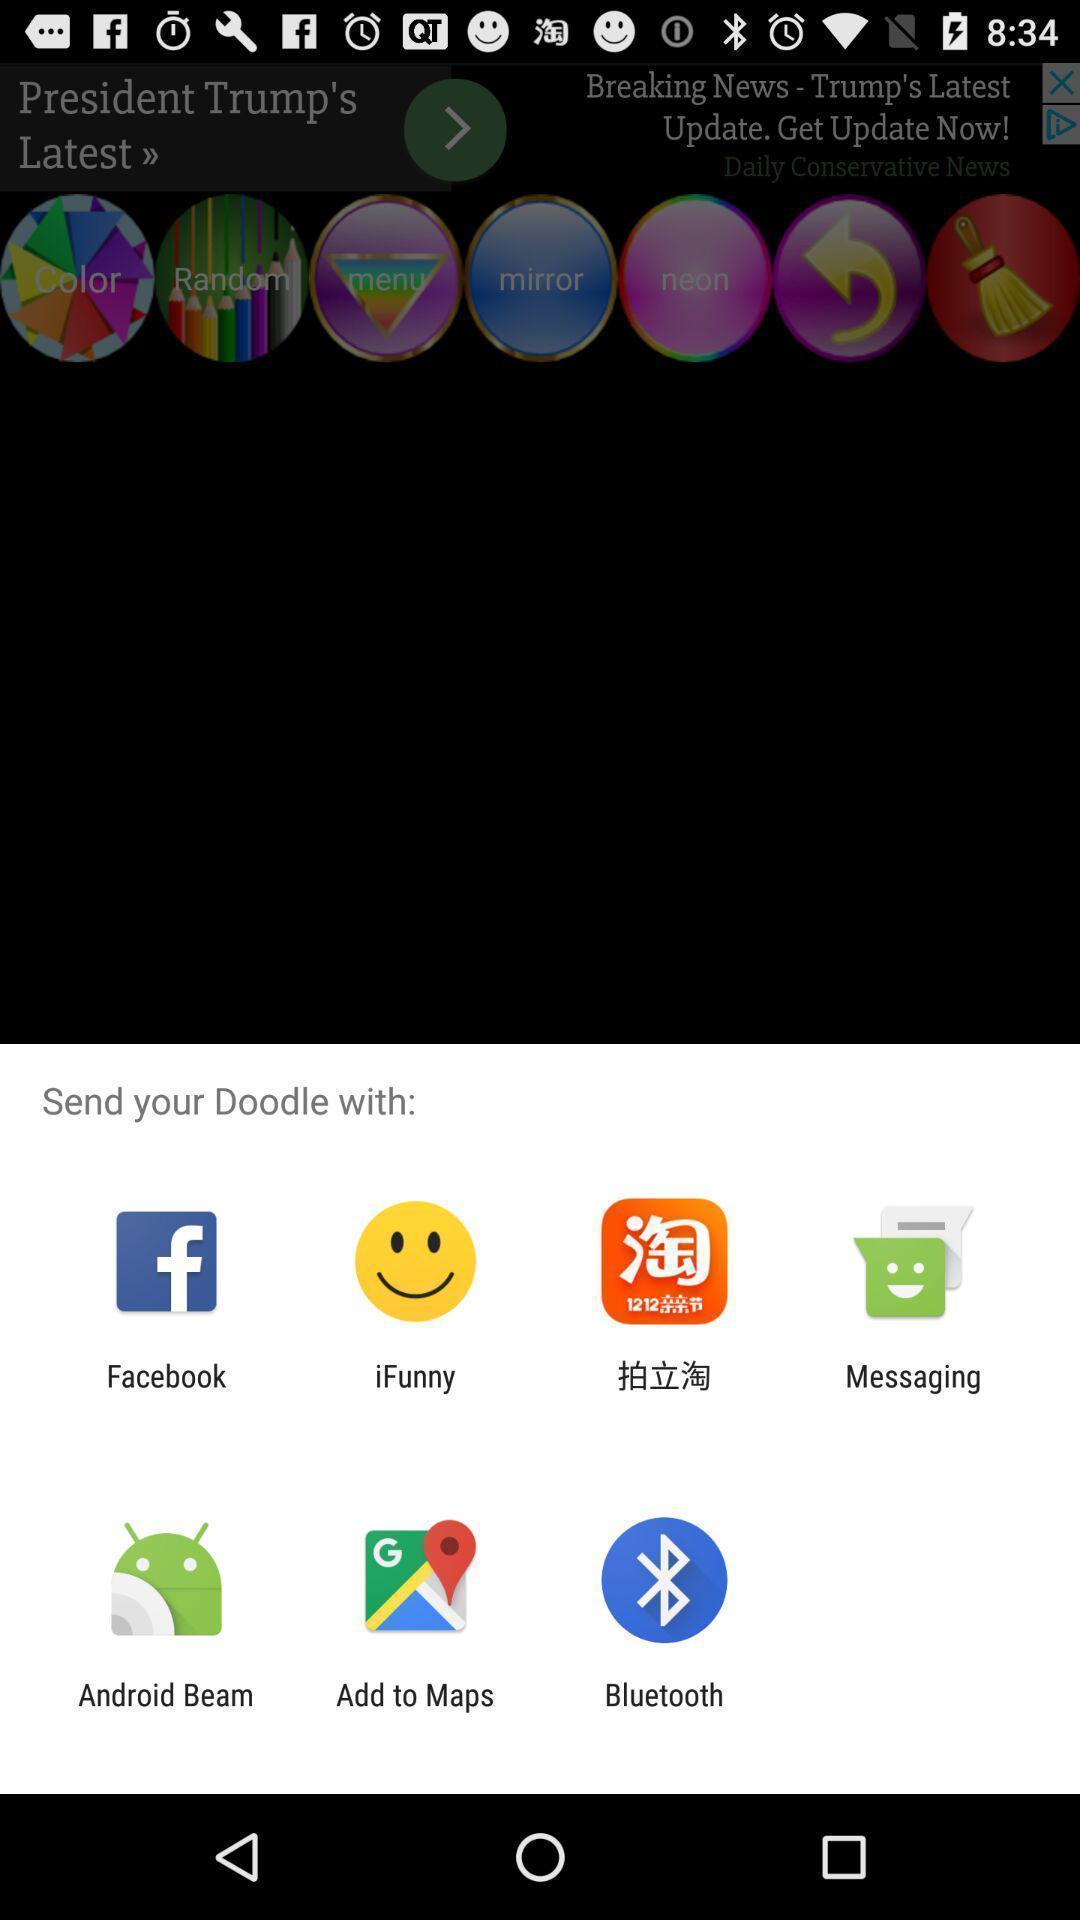Summarize the main components in this picture. Pop up to share through various applications. 